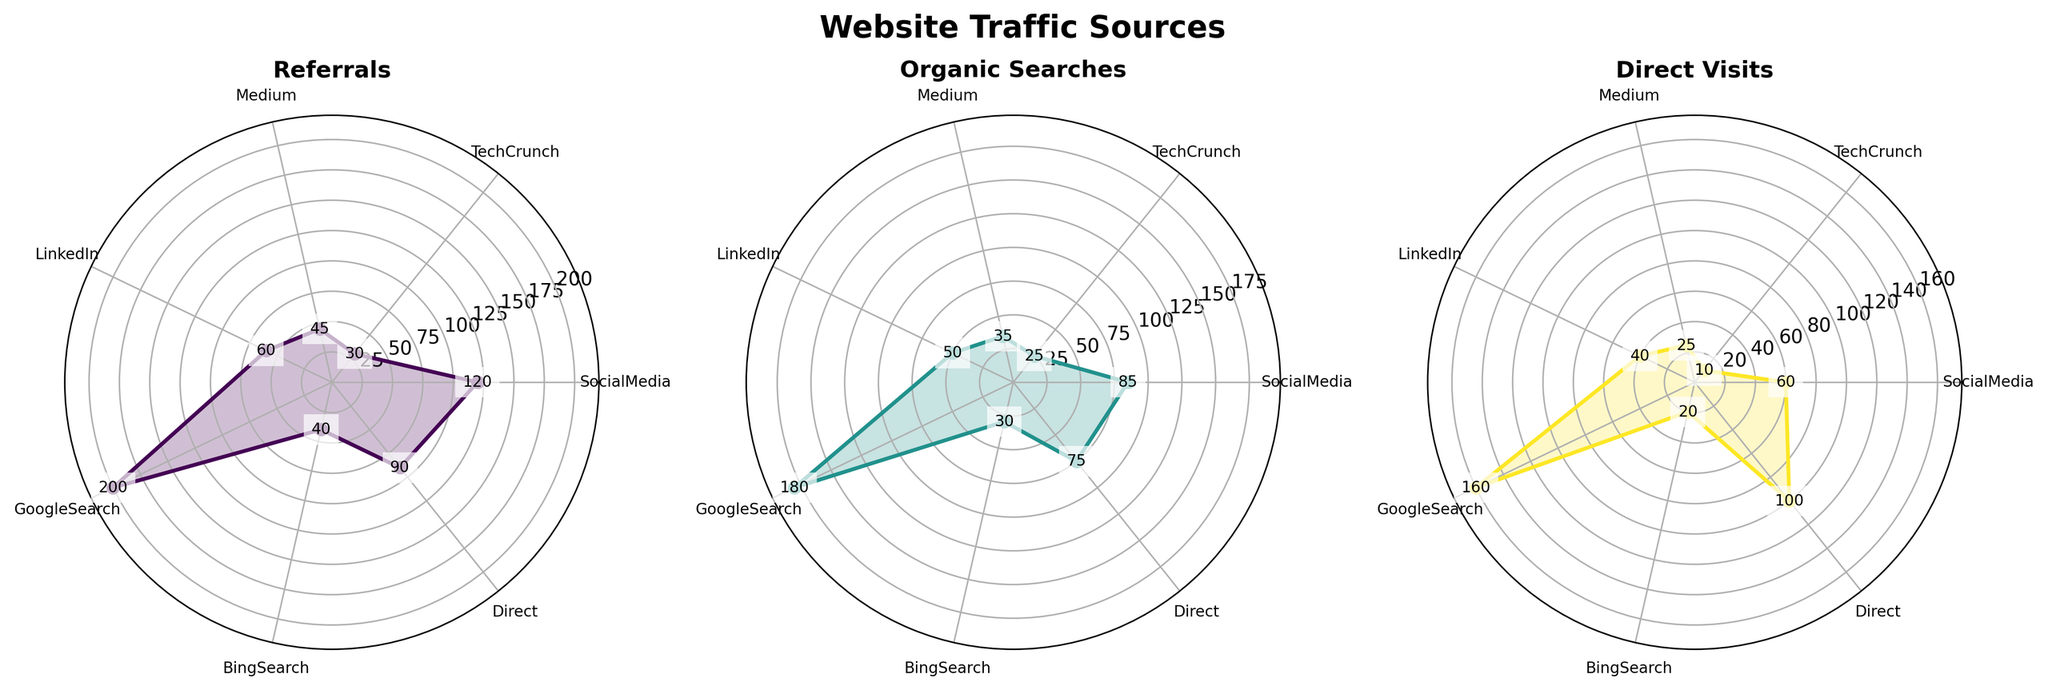What's the title of the figure? The figure title is found at the top-center and denotes what the figure represents.
Answer: Website Traffic Sources How many traffic sources are represented in the plots? Each plot has an equal number of segments corresponding to the traffic sources labeled around the plot. Count these labels.
Answer: 7 Which source has the highest organic searches? Comparing the radial height of each segment in the "Organic Searches" subplot, the highest point labels "GoogleSearch".
Answer: GoogleSearch What is the median number of referrals from all sources? To find the median, list all referral values: 120, 30, 45, 60, 200, 40, 90. Order them: 30, 40, 45, 60, 90, 120, 200. The middle value is 60.
Answer: 60 Which traffic source contributes the least to direct visits? By comparing the smallest radial length in the "Direct Visits" subplot, it points to "TechCrunch".
Answer: TechCrunch Are there any sources with an equal number of direct visits? Compare the radial heights in the "Direct Visits" subplot. Both "BingSearch" and "TechCrunch" have equal lengths indicating the same number of direct visits.
Answer: Yes What's the proportion of organic searches from LinkedIn compared to GoogleSearch? LinkedIn has 50, and GoogleSearch has 180 organic searches. The proportion is 50/180, which simplifies to approximately 0.278.
Answer: 0.278 Which source has equal referrals and direct visits? In the "Referrals" and "Direct Visits" subplots, check if any source has the same radial height for both. "Direct" has 90 for both.
Answer: Direct By how much do Google's direct visits exceed Bing's direct visits? Google's direct visits are labeled as 160 and Bing's as 20. Subtract Bing's visits from Google's: 160 - 20.
Answer: 140 Which plot has the highest maximum value, and what is it? Checking the outermost point in each subplot, the highest value is in "Organic Searches" with 200 from GoogleSearch.
Answer: Organic Searches, 200 